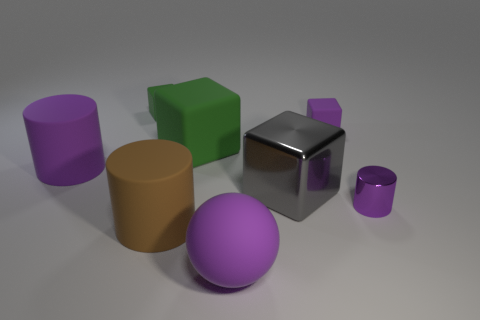Subtract all purple cylinders. How many cylinders are left? 1 Add 1 large metallic objects. How many objects exist? 9 Subtract all purple cubes. How many cubes are left? 3 Subtract 1 cylinders. How many cylinders are left? 2 Subtract all small gray metal objects. Subtract all big matte balls. How many objects are left? 7 Add 5 small blocks. How many small blocks are left? 7 Add 6 tiny green objects. How many tiny green objects exist? 7 Subtract 0 blue cylinders. How many objects are left? 8 Subtract all balls. How many objects are left? 7 Subtract all yellow spheres. Subtract all green blocks. How many spheres are left? 1 